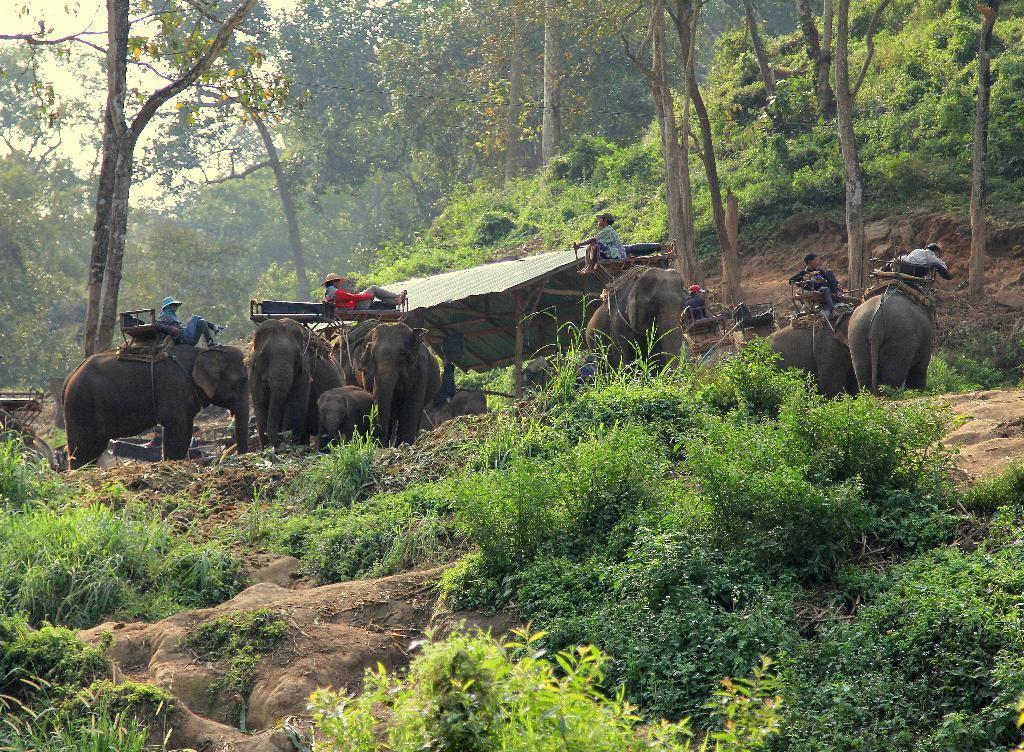What animals are present in the image? There are elephants in the image. What are the people doing while sitting on the elephants? The people are sitting on the elephants. What can be seen in the background of the image? There are trees and small plants in the background of the image. What type of star can be seen shining above the elephants in the image? There is no star visible in the image; it is focused on the elephants and people sitting on them. 